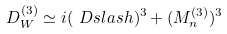Convert formula to latex. <formula><loc_0><loc_0><loc_500><loc_500>D _ { W } ^ { ( 3 ) } \simeq i ( \ D s l a s h ) ^ { 3 } + ( M _ { n } ^ { ( 3 ) } ) ^ { 3 }</formula> 